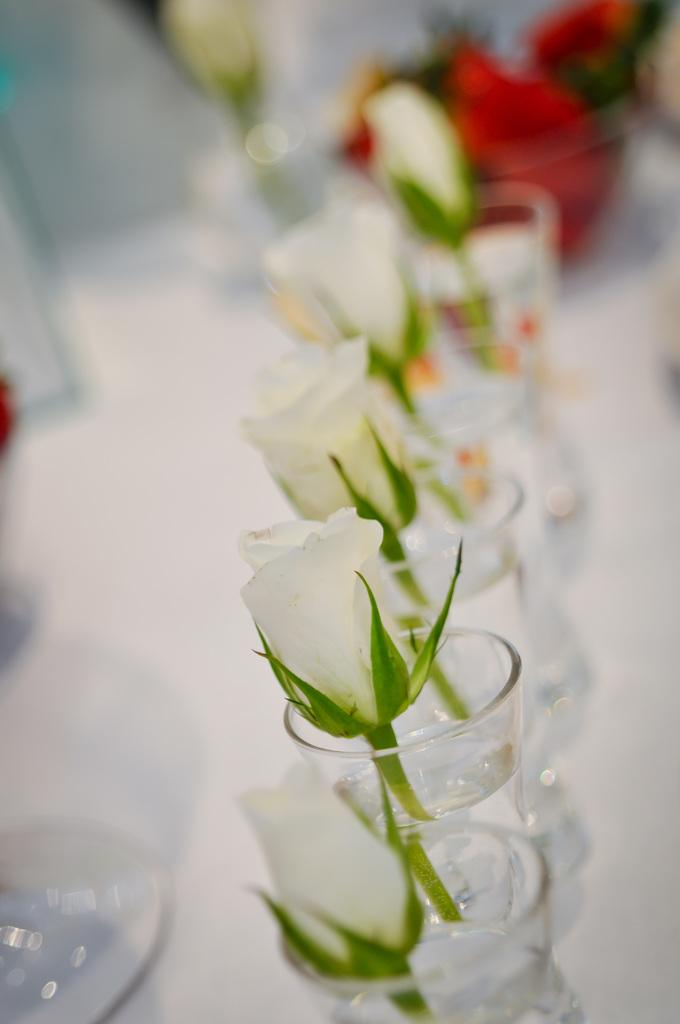What is in the glasses that are visible in the image? There are glasses with water in the image. What is added to the water in the glasses? There are roses in the glasses. On what surface are the glasses placed? The glasses are placed on a white surface. Can you describe the background of the image? The background of the image is blurred. What type of quartz can be seen in the image? There is no quartz present in the image. Can you describe the seat in the image? There is no seat present in the image. 